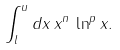Convert formula to latex. <formula><loc_0><loc_0><loc_500><loc_500>\int _ { l } ^ { u } d x \, x ^ { n } \, \ln ^ { p } x .</formula> 